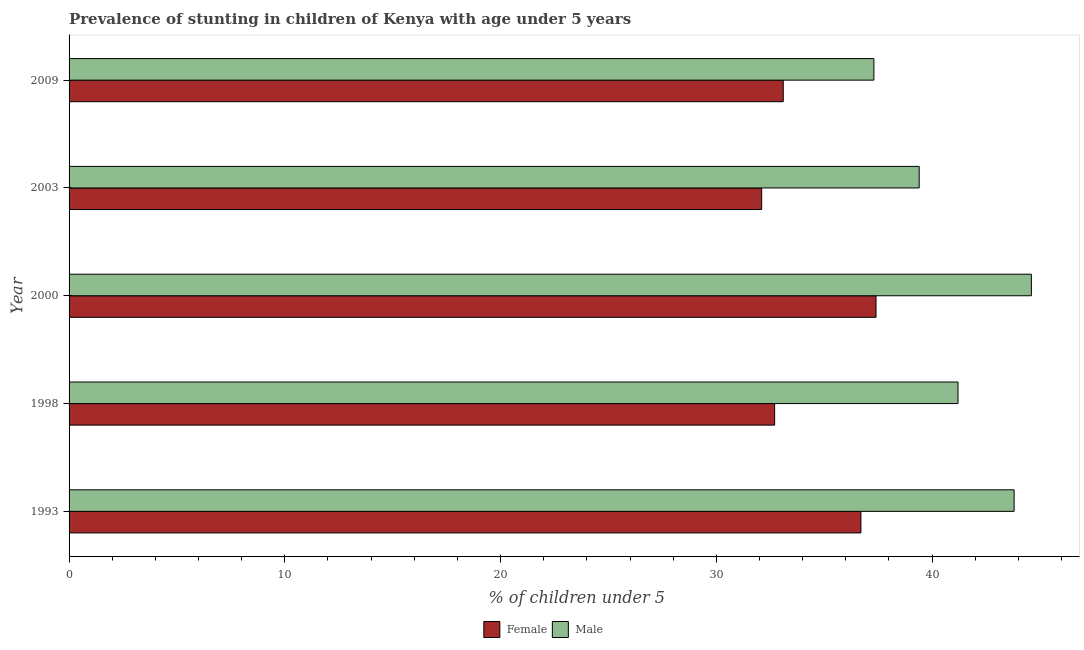How many groups of bars are there?
Make the answer very short. 5. How many bars are there on the 4th tick from the top?
Ensure brevity in your answer.  2. How many bars are there on the 2nd tick from the bottom?
Provide a short and direct response. 2. What is the percentage of stunted female children in 2003?
Your answer should be very brief. 32.1. Across all years, what is the maximum percentage of stunted male children?
Your response must be concise. 44.6. Across all years, what is the minimum percentage of stunted female children?
Your answer should be very brief. 32.1. In which year was the percentage of stunted female children minimum?
Offer a very short reply. 2003. What is the total percentage of stunted female children in the graph?
Keep it short and to the point. 172. What is the difference between the percentage of stunted male children in 2000 and the percentage of stunted female children in 1998?
Provide a short and direct response. 11.9. What is the average percentage of stunted male children per year?
Your response must be concise. 41.26. In the year 2000, what is the difference between the percentage of stunted male children and percentage of stunted female children?
Provide a succinct answer. 7.2. In how many years, is the percentage of stunted female children greater than 14 %?
Keep it short and to the point. 5. What is the ratio of the percentage of stunted female children in 1993 to that in 1998?
Keep it short and to the point. 1.12. What is the difference between the highest and the second highest percentage of stunted female children?
Offer a very short reply. 0.7. In how many years, is the percentage of stunted female children greater than the average percentage of stunted female children taken over all years?
Ensure brevity in your answer.  2. How many bars are there?
Ensure brevity in your answer.  10. Are all the bars in the graph horizontal?
Your response must be concise. Yes. How many years are there in the graph?
Offer a very short reply. 5. Are the values on the major ticks of X-axis written in scientific E-notation?
Your answer should be very brief. No. How many legend labels are there?
Your response must be concise. 2. How are the legend labels stacked?
Your response must be concise. Horizontal. What is the title of the graph?
Make the answer very short. Prevalence of stunting in children of Kenya with age under 5 years. Does "Official aid received" appear as one of the legend labels in the graph?
Your response must be concise. No. What is the label or title of the X-axis?
Your answer should be very brief.  % of children under 5. What is the  % of children under 5 in Female in 1993?
Offer a very short reply. 36.7. What is the  % of children under 5 in Male in 1993?
Keep it short and to the point. 43.8. What is the  % of children under 5 in Female in 1998?
Your answer should be compact. 32.7. What is the  % of children under 5 of Male in 1998?
Keep it short and to the point. 41.2. What is the  % of children under 5 in Female in 2000?
Offer a very short reply. 37.4. What is the  % of children under 5 in Male in 2000?
Provide a succinct answer. 44.6. What is the  % of children under 5 of Female in 2003?
Offer a terse response. 32.1. What is the  % of children under 5 of Male in 2003?
Your answer should be compact. 39.4. What is the  % of children under 5 in Female in 2009?
Provide a succinct answer. 33.1. What is the  % of children under 5 in Male in 2009?
Your answer should be very brief. 37.3. Across all years, what is the maximum  % of children under 5 in Female?
Your answer should be very brief. 37.4. Across all years, what is the maximum  % of children under 5 of Male?
Offer a terse response. 44.6. Across all years, what is the minimum  % of children under 5 in Female?
Give a very brief answer. 32.1. Across all years, what is the minimum  % of children under 5 of Male?
Your answer should be very brief. 37.3. What is the total  % of children under 5 of Female in the graph?
Provide a short and direct response. 172. What is the total  % of children under 5 of Male in the graph?
Give a very brief answer. 206.3. What is the difference between the  % of children under 5 of Female in 1993 and that in 1998?
Offer a terse response. 4. What is the difference between the  % of children under 5 in Male in 1993 and that in 1998?
Ensure brevity in your answer.  2.6. What is the difference between the  % of children under 5 of Female in 1993 and that in 2000?
Provide a short and direct response. -0.7. What is the difference between the  % of children under 5 of Male in 1993 and that in 2000?
Offer a terse response. -0.8. What is the difference between the  % of children under 5 in Female in 1993 and that in 2009?
Keep it short and to the point. 3.6. What is the difference between the  % of children under 5 in Male in 1998 and that in 2000?
Your answer should be very brief. -3.4. What is the difference between the  % of children under 5 in Female in 1998 and that in 2003?
Offer a terse response. 0.6. What is the difference between the  % of children under 5 of Male in 1998 and that in 2003?
Your answer should be compact. 1.8. What is the difference between the  % of children under 5 of Male in 2000 and that in 2003?
Make the answer very short. 5.2. What is the difference between the  % of children under 5 in Female in 2000 and that in 2009?
Offer a very short reply. 4.3. What is the difference between the  % of children under 5 of Male in 2000 and that in 2009?
Give a very brief answer. 7.3. What is the difference between the  % of children under 5 in Female in 2003 and that in 2009?
Your answer should be compact. -1. What is the difference between the  % of children under 5 in Male in 2003 and that in 2009?
Provide a succinct answer. 2.1. What is the difference between the  % of children under 5 of Female in 1993 and the  % of children under 5 of Male in 1998?
Your response must be concise. -4.5. What is the difference between the  % of children under 5 of Female in 1993 and the  % of children under 5 of Male in 2000?
Ensure brevity in your answer.  -7.9. What is the difference between the  % of children under 5 of Female in 1993 and the  % of children under 5 of Male in 2003?
Your answer should be very brief. -2.7. What is the difference between the  % of children under 5 in Female in 1998 and the  % of children under 5 in Male in 2000?
Keep it short and to the point. -11.9. What is the difference between the  % of children under 5 in Female in 1998 and the  % of children under 5 in Male in 2009?
Make the answer very short. -4.6. What is the difference between the  % of children under 5 of Female in 2003 and the  % of children under 5 of Male in 2009?
Keep it short and to the point. -5.2. What is the average  % of children under 5 in Female per year?
Make the answer very short. 34.4. What is the average  % of children under 5 in Male per year?
Your answer should be very brief. 41.26. In the year 1998, what is the difference between the  % of children under 5 of Female and  % of children under 5 of Male?
Provide a succinct answer. -8.5. In the year 2000, what is the difference between the  % of children under 5 in Female and  % of children under 5 in Male?
Your answer should be very brief. -7.2. In the year 2003, what is the difference between the  % of children under 5 in Female and  % of children under 5 in Male?
Offer a terse response. -7.3. In the year 2009, what is the difference between the  % of children under 5 in Female and  % of children under 5 in Male?
Give a very brief answer. -4.2. What is the ratio of the  % of children under 5 of Female in 1993 to that in 1998?
Offer a very short reply. 1.12. What is the ratio of the  % of children under 5 of Male in 1993 to that in 1998?
Offer a very short reply. 1.06. What is the ratio of the  % of children under 5 in Female in 1993 to that in 2000?
Offer a very short reply. 0.98. What is the ratio of the  % of children under 5 of Male in 1993 to that in 2000?
Make the answer very short. 0.98. What is the ratio of the  % of children under 5 of Female in 1993 to that in 2003?
Provide a succinct answer. 1.14. What is the ratio of the  % of children under 5 in Male in 1993 to that in 2003?
Keep it short and to the point. 1.11. What is the ratio of the  % of children under 5 in Female in 1993 to that in 2009?
Your answer should be very brief. 1.11. What is the ratio of the  % of children under 5 of Male in 1993 to that in 2009?
Your answer should be compact. 1.17. What is the ratio of the  % of children under 5 of Female in 1998 to that in 2000?
Provide a succinct answer. 0.87. What is the ratio of the  % of children under 5 in Male in 1998 to that in 2000?
Your response must be concise. 0.92. What is the ratio of the  % of children under 5 of Female in 1998 to that in 2003?
Give a very brief answer. 1.02. What is the ratio of the  % of children under 5 of Male in 1998 to that in 2003?
Ensure brevity in your answer.  1.05. What is the ratio of the  % of children under 5 in Female in 1998 to that in 2009?
Your answer should be very brief. 0.99. What is the ratio of the  % of children under 5 of Male in 1998 to that in 2009?
Ensure brevity in your answer.  1.1. What is the ratio of the  % of children under 5 of Female in 2000 to that in 2003?
Your response must be concise. 1.17. What is the ratio of the  % of children under 5 of Male in 2000 to that in 2003?
Ensure brevity in your answer.  1.13. What is the ratio of the  % of children under 5 of Female in 2000 to that in 2009?
Your response must be concise. 1.13. What is the ratio of the  % of children under 5 in Male in 2000 to that in 2009?
Make the answer very short. 1.2. What is the ratio of the  % of children under 5 of Female in 2003 to that in 2009?
Make the answer very short. 0.97. What is the ratio of the  % of children under 5 of Male in 2003 to that in 2009?
Offer a very short reply. 1.06. What is the difference between the highest and the second highest  % of children under 5 in Female?
Provide a short and direct response. 0.7. What is the difference between the highest and the lowest  % of children under 5 in Male?
Provide a short and direct response. 7.3. 